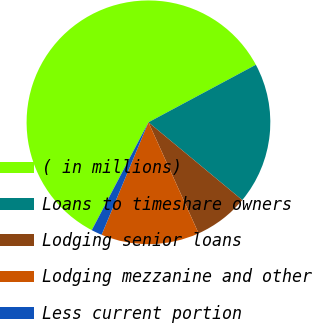<chart> <loc_0><loc_0><loc_500><loc_500><pie_chart><fcel>( in millions)<fcel>Loans to timeshare owners<fcel>Lodging senior loans<fcel>Lodging mezzanine and other<fcel>Less current portion<nl><fcel>59.47%<fcel>18.84%<fcel>7.23%<fcel>13.03%<fcel>1.42%<nl></chart> 